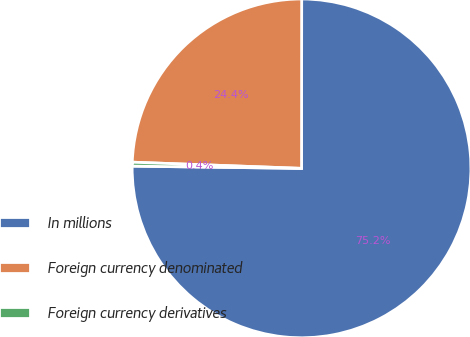Convert chart to OTSL. <chart><loc_0><loc_0><loc_500><loc_500><pie_chart><fcel>In millions<fcel>Foreign currency denominated<fcel>Foreign currency derivatives<nl><fcel>75.2%<fcel>24.43%<fcel>0.37%<nl></chart> 